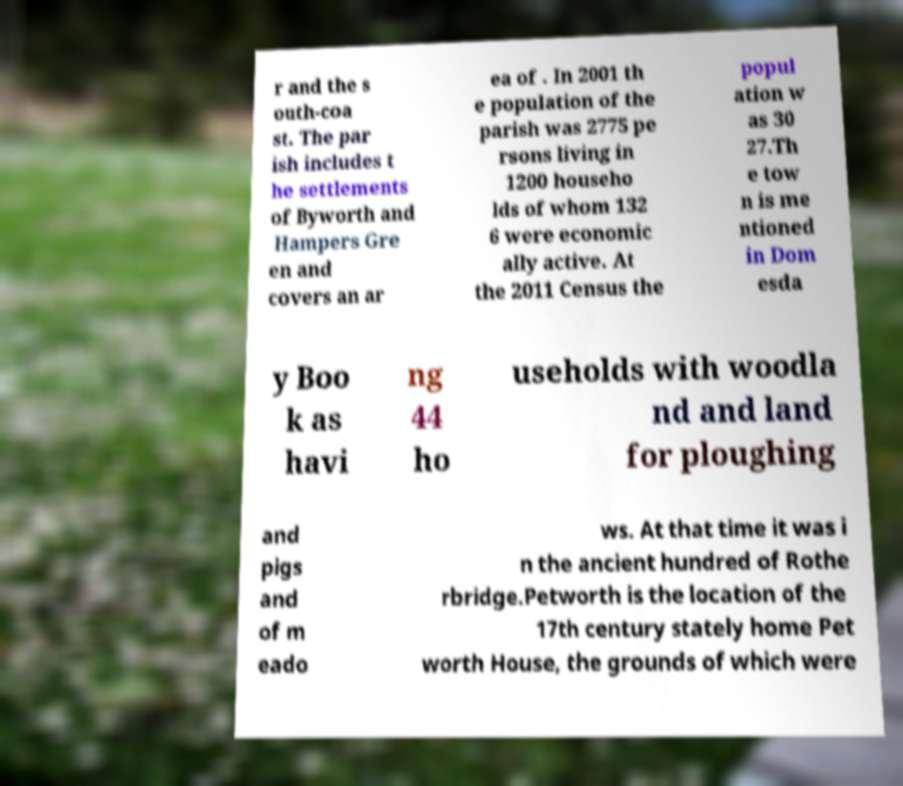Can you accurately transcribe the text from the provided image for me? r and the s outh-coa st. The par ish includes t he settlements of Byworth and Hampers Gre en and covers an ar ea of . In 2001 th e population of the parish was 2775 pe rsons living in 1200 househo lds of whom 132 6 were economic ally active. At the 2011 Census the popul ation w as 30 27.Th e tow n is me ntioned in Dom esda y Boo k as havi ng 44 ho useholds with woodla nd and land for ploughing and pigs and of m eado ws. At that time it was i n the ancient hundred of Rothe rbridge.Petworth is the location of the 17th century stately home Pet worth House, the grounds of which were 